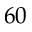Convert formula to latex. <formula><loc_0><loc_0><loc_500><loc_500>6 0</formula> 